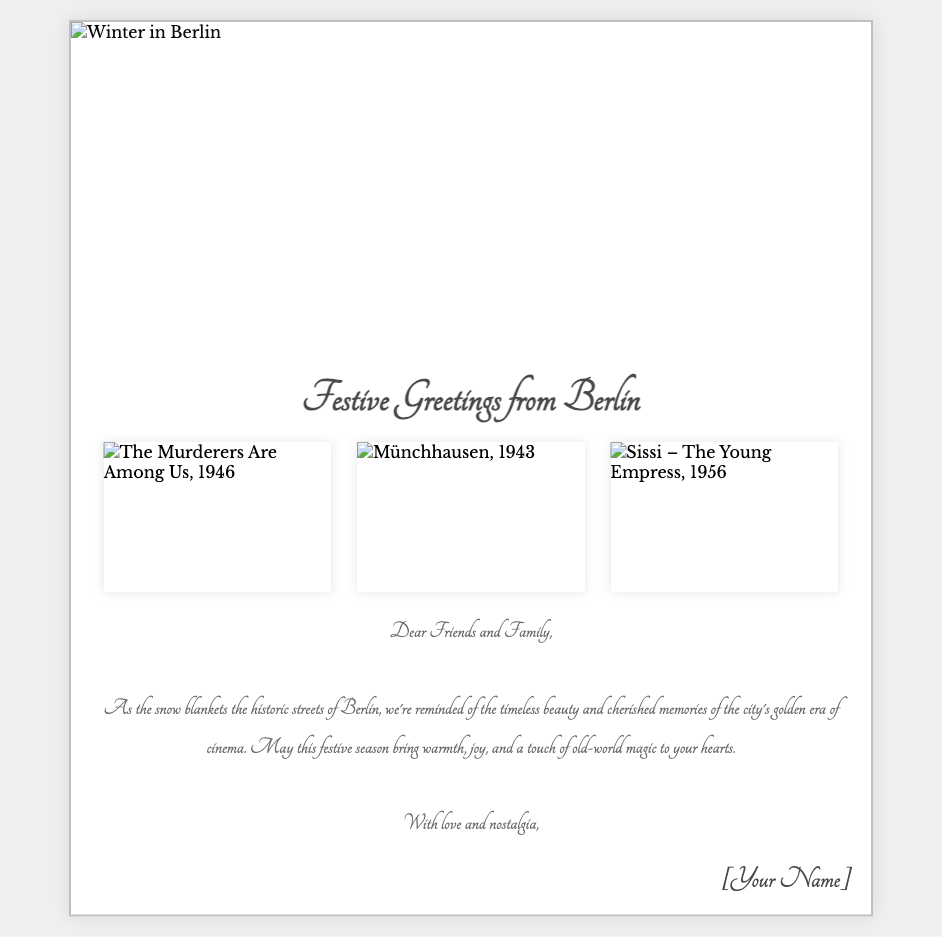What is the title of the card? The title is prominently displayed at the top of the card, which is "Festive Greetings from Berlin."
Answer: Festive Greetings from Berlin How many images are in the image gallery? The card displays three images in the image gallery section.
Answer: 3 What year was "The Murderers Are Among Us" released? The card features this film, which was released in 1946.
Answer: 1946 What color is the background of the card? The background of the card is a light gray color, #f0f0f0.
Answer: Light gray What is the message's main theme? The message reflects on the beauty and memories of Berlin's golden era of cinema during the festive season.
Answer: Timeless beauty and cherished memories Where is the snowflake symbol located? The snowflake symbols are positioned at various places: top-left, top-right, and bottom-left corners of the card.
Answer: Various positions What style is the font used for the message? The font used for the message is a handwritten cursive style named 'Tangerine.'
Answer: Handwritten cursive What holiday sentiment does the card convey? The card conveys warmth, joy, and nostalgia during the festive season.
Answer: Warmth, joy, and nostalgia 